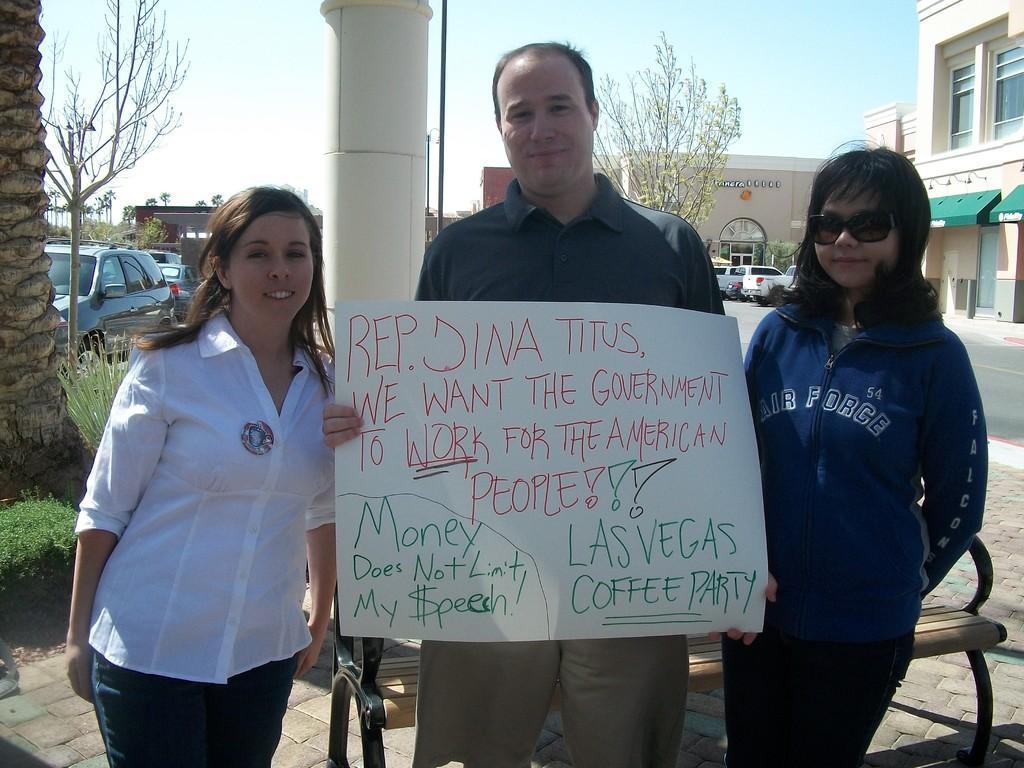Describe this image in one or two sentences. In the center of the image we can see three people are standing. Among them, we can see one person is holding a banner with some text and one person is wearing glasses. In the background, we can see the sky, buildings, trees, vehicles and a few other objects. 